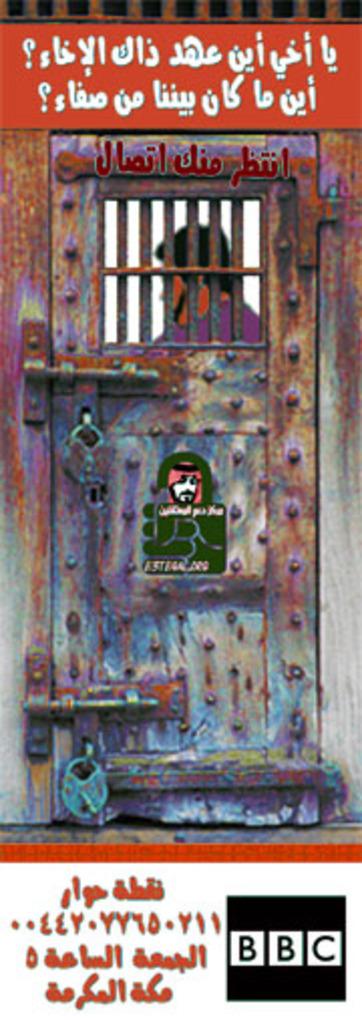What letters are in the black box?
Your answer should be very brief. Bbc. 